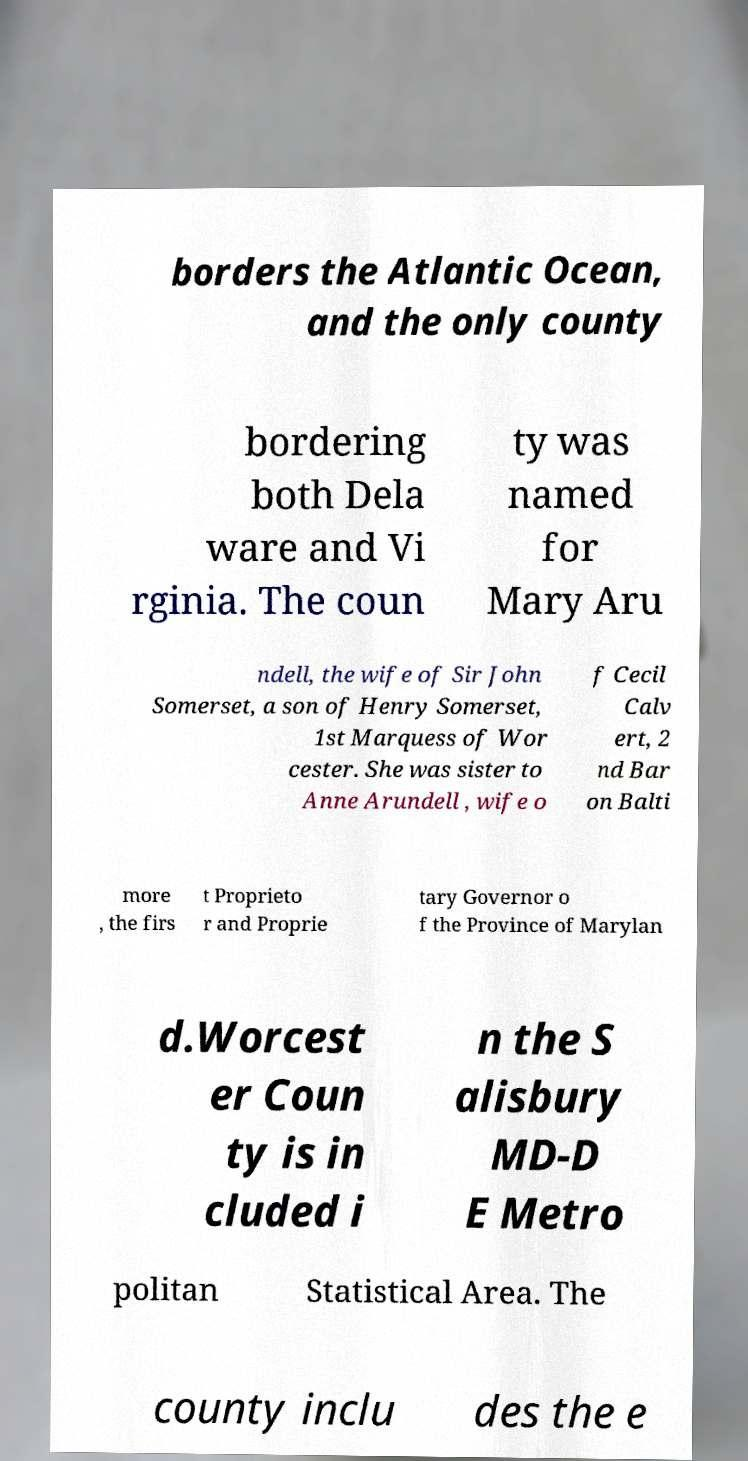For documentation purposes, I need the text within this image transcribed. Could you provide that? borders the Atlantic Ocean, and the only county bordering both Dela ware and Vi rginia. The coun ty was named for Mary Aru ndell, the wife of Sir John Somerset, a son of Henry Somerset, 1st Marquess of Wor cester. She was sister to Anne Arundell , wife o f Cecil Calv ert, 2 nd Bar on Balti more , the firs t Proprieto r and Proprie tary Governor o f the Province of Marylan d.Worcest er Coun ty is in cluded i n the S alisbury MD-D E Metro politan Statistical Area. The county inclu des the e 